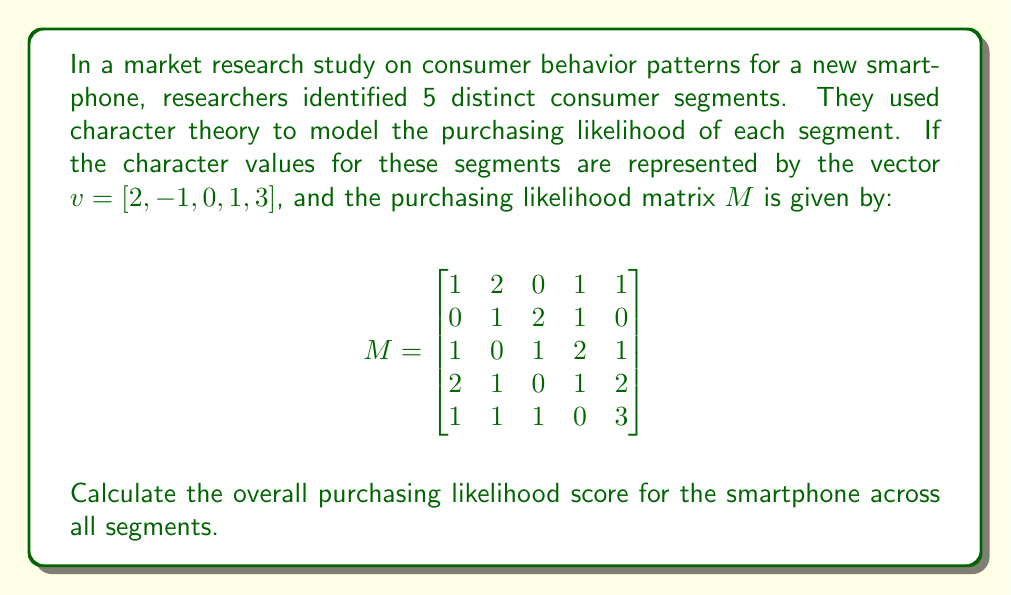Provide a solution to this math problem. To solve this problem, we need to apply character theory concepts to the given market research scenario. Here's a step-by-step explanation:

1. In character theory, the overall score is calculated by multiplying the character vector with the matrix. This is represented as $vM$.

2. To perform this multiplication, we need to multiply the vector $v$ with each column of matrix $M$ and sum the results. Let's break it down:

   a. For the first column: $(2 \times 1) + (-1 \times 0) + (0 \times 1) + (1 \times 2) + (3 \times 1) = 2 + 0 + 0 + 2 + 3 = 7$
   
   b. For the second column: $(2 \times 2) + (-1 \times 1) + (0 \times 0) + (1 \times 1) + (3 \times 1) = 4 - 1 + 0 + 1 + 3 = 7$
   
   c. For the third column: $(2 \times 0) + (-1 \times 2) + (0 \times 1) + (1 \times 0) + (3 \times 1) = 0 - 2 + 0 + 0 + 3 = 1$
   
   d. For the fourth column: $(2 \times 1) + (-1 \times 1) + (0 \times 2) + (1 \times 1) + (3 \times 0) = 2 - 1 + 0 + 1 + 0 = 2$
   
   e. For the fifth column: $(2 \times 1) + (-1 \times 0) + (0 \times 1) + (1 \times 2) + (3 \times 3) = 2 + 0 + 0 + 2 + 9 = 13$

3. The resulting vector after multiplication is $[7, 7, 1, 2, 13]$.

4. To get the overall purchasing likelihood score, we sum up all the elements of this resulting vector:

   $7 + 7 + 1 + 2 + 13 = 30$

Therefore, the overall purchasing likelihood score for the smartphone across all segments is 30.
Answer: 30 